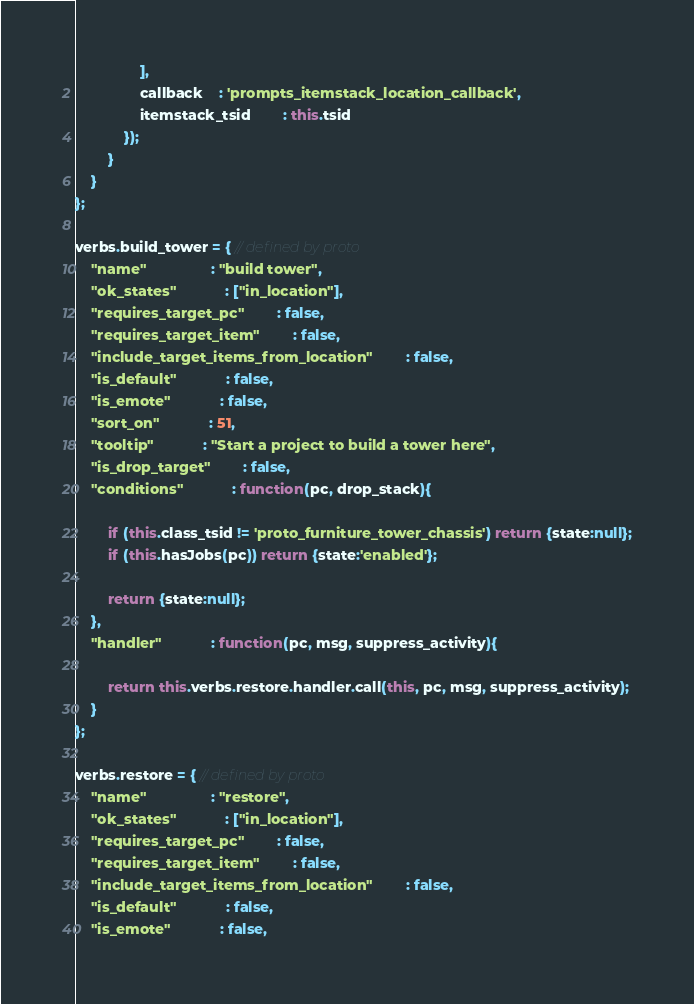<code> <loc_0><loc_0><loc_500><loc_500><_JavaScript_>				],
				callback	: 'prompts_itemstack_location_callback',
				itemstack_tsid		: this.tsid
			});
		}
	}
};

verbs.build_tower = { // defined by proto
	"name"				: "build tower",
	"ok_states"			: ["in_location"],
	"requires_target_pc"		: false,
	"requires_target_item"		: false,
	"include_target_items_from_location"		: false,
	"is_default"			: false,
	"is_emote"			: false,
	"sort_on"			: 51,
	"tooltip"			: "Start a project to build a tower here",
	"is_drop_target"		: false,
	"conditions"			: function(pc, drop_stack){

		if (this.class_tsid != 'proto_furniture_tower_chassis') return {state:null};
		if (this.hasJobs(pc)) return {state:'enabled'};

		return {state:null};
	},
	"handler"			: function(pc, msg, suppress_activity){

		return this.verbs.restore.handler.call(this, pc, msg, suppress_activity);
	}
};

verbs.restore = { // defined by proto
	"name"				: "restore",
	"ok_states"			: ["in_location"],
	"requires_target_pc"		: false,
	"requires_target_item"		: false,
	"include_target_items_from_location"		: false,
	"is_default"			: false,
	"is_emote"			: false,</code> 